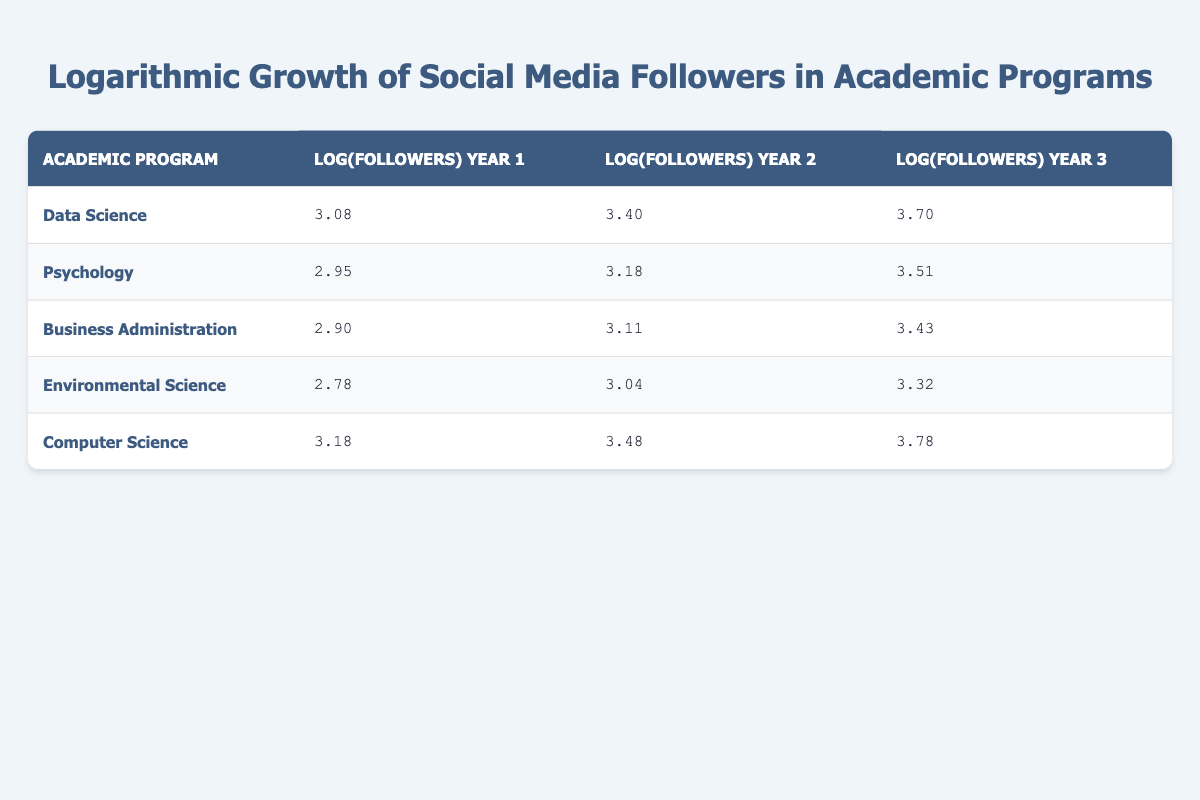What is the logarithmic value of followers for the Data Science program in Year 3? The table directly shows that for the Data Science program, the logarithmic value of followers in Year 3 is 3.70.
Answer: 3.70 Which program had the highest log value increase from Year 1 to Year 3? For each program, I will calculate the difference between Year 3 and Year 1. Data Science: 3.70 - 3.08 = 0.62, Psychology: 3.51 - 2.95 = 0.56, Business Administration: 3.43 - 2.90 = 0.53, Environmental Science: 3.32 - 2.78 = 0.54, and Computer Science: 3.78 - 3.18 = 0.60. The highest increase is for Data Science at 0.62.
Answer: Data Science Is the logarithmic value of followers for the Psychology program in Year 2 greater than 3.00? Looking at the data, the logarithmic value for Psychology in Year 2 is 3.18, which is greater than 3.00.
Answer: Yes What is the average logarithmic value of followers across all programs in Year 2? To find the average, I first sum the values for Year 2: 3.40 (Data Science) + 3.18 (Psychology) + 3.11 (Business Administration) + 3.04 (Environmental Science) + 3.48 (Computer Science) = 16.21. Then, I divide by the number of programs (5): 16.21 / 5 = 3.24.
Answer: 3.24 Which program had a higher logarithmic growth in Year 2 compared to Environmental Science? In Year 2, Environmental Science has a log value of 3.04. I will compare it with the log values of the other programs: Data Science (3.40), Psychology (3.18), Business Administration (3.11), Computer Science (3.48). The programs that had higher values in Year 2 than Environmental Science are Data Science and Computer Science.
Answer: Data Science and Computer Science 